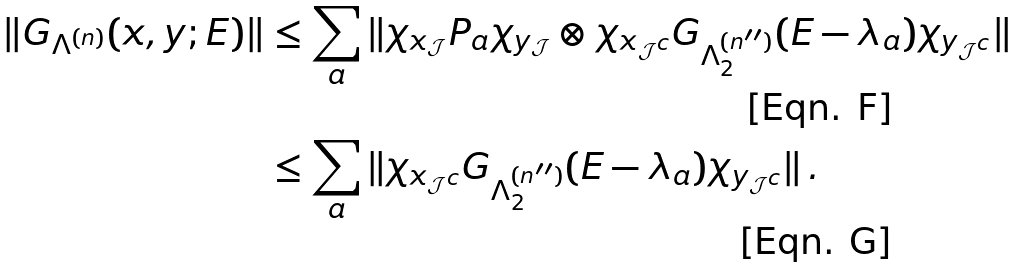Convert formula to latex. <formula><loc_0><loc_0><loc_500><loc_500>\| G _ { \Lambda ^ { ( n ) } } ( x , y ; E ) \| & \leq \sum _ { a } \| \chi _ { x _ { \mathcal { J } } } P _ { a } \chi _ { y _ { \mathcal { J } } } \otimes \chi _ { x _ { \mathcal { J } ^ { c } } } G _ { \Lambda _ { 2 } ^ { ( n ^ { \prime \prime } ) } } ( E - \lambda _ { a } ) \chi _ { y _ { \mathcal { J } ^ { c } } } \| \\ & \leq \sum _ { a } \| \chi _ { x _ { \mathcal { J } ^ { c } } } G _ { \Lambda _ { 2 } ^ { ( n ^ { \prime \prime } ) } } ( E - \lambda _ { a } ) \chi _ { y _ { \mathcal { J } ^ { c } } } \| \, .</formula> 